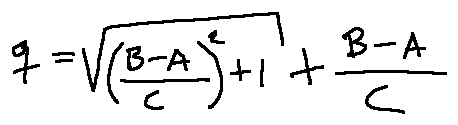Convert formula to latex. <formula><loc_0><loc_0><loc_500><loc_500>q = \sqrt { ( \frac { B - A } { C } ) ^ { 2 } + 1 } + \frac { B - A } { C }</formula> 